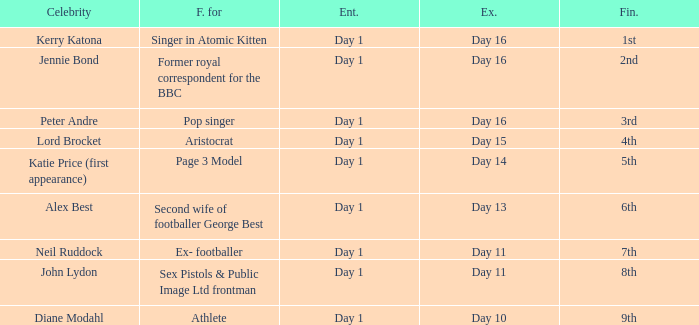Name the finished for kerry katona 1.0. 